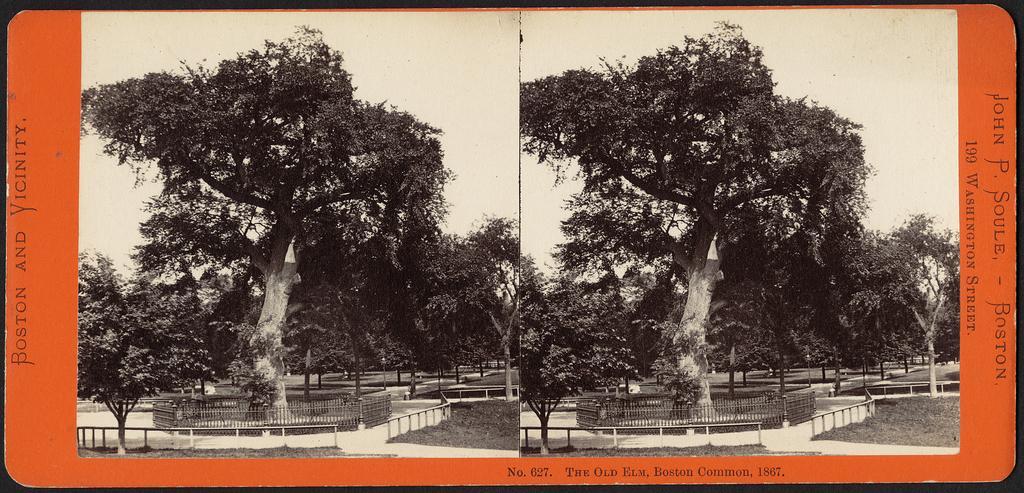How would you summarize this image in a sentence or two? In the image I can see the collage picture. I can see the trees. There is a metal fence around the tree. 